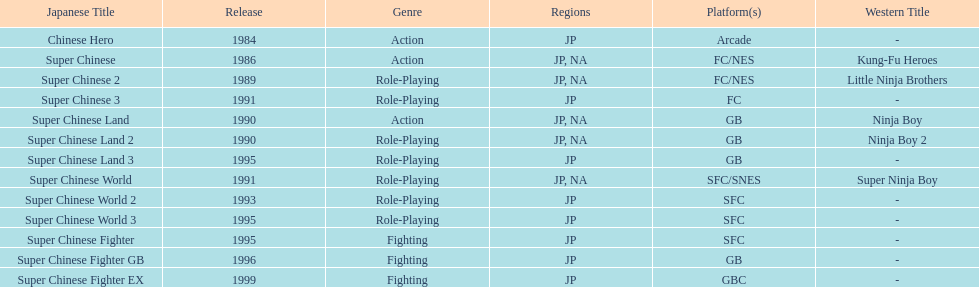Give me the full table as a dictionary. {'header': ['Japanese Title', 'Release', 'Genre', 'Regions', 'Platform(s)', 'Western Title'], 'rows': [['Chinese Hero', '1984', 'Action', 'JP', 'Arcade', '-'], ['Super Chinese', '1986', 'Action', 'JP, NA', 'FC/NES', 'Kung-Fu Heroes'], ['Super Chinese 2', '1989', 'Role-Playing', 'JP, NA', 'FC/NES', 'Little Ninja Brothers'], ['Super Chinese 3', '1991', 'Role-Playing', 'JP', 'FC', '-'], ['Super Chinese Land', '1990', 'Action', 'JP, NA', 'GB', 'Ninja Boy'], ['Super Chinese Land 2', '1990', 'Role-Playing', 'JP, NA', 'GB', 'Ninja Boy 2'], ['Super Chinese Land 3', '1995', 'Role-Playing', 'JP', 'GB', '-'], ['Super Chinese World', '1991', 'Role-Playing', 'JP, NA', 'SFC/SNES', 'Super Ninja Boy'], ['Super Chinese World 2', '1993', 'Role-Playing', 'JP', 'SFC', '-'], ['Super Chinese World 3', '1995', 'Role-Playing', 'JP', 'SFC', '-'], ['Super Chinese Fighter', '1995', 'Fighting', 'JP', 'SFC', '-'], ['Super Chinese Fighter GB', '1996', 'Fighting', 'JP', 'GB', '-'], ['Super Chinese Fighter EX', '1999', 'Fighting', 'JP', 'GBC', '-']]} What is the overall count of super chinese games released? 13. 